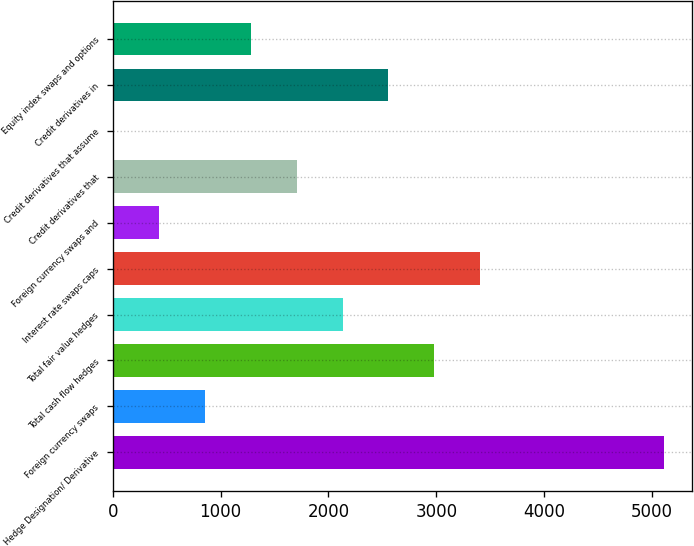Convert chart to OTSL. <chart><loc_0><loc_0><loc_500><loc_500><bar_chart><fcel>Hedge Designation/ Derivative<fcel>Foreign currency swaps<fcel>Total cash flow hedges<fcel>Total fair value hedges<fcel>Interest rate swaps caps<fcel>Foreign currency swaps and<fcel>Credit derivatives that<fcel>Credit derivatives that assume<fcel>Credit derivatives in<fcel>Equity index swaps and options<nl><fcel>5111.6<fcel>853.6<fcel>2982.6<fcel>2131<fcel>3408.4<fcel>427.8<fcel>1705.2<fcel>2<fcel>2556.8<fcel>1279.4<nl></chart> 